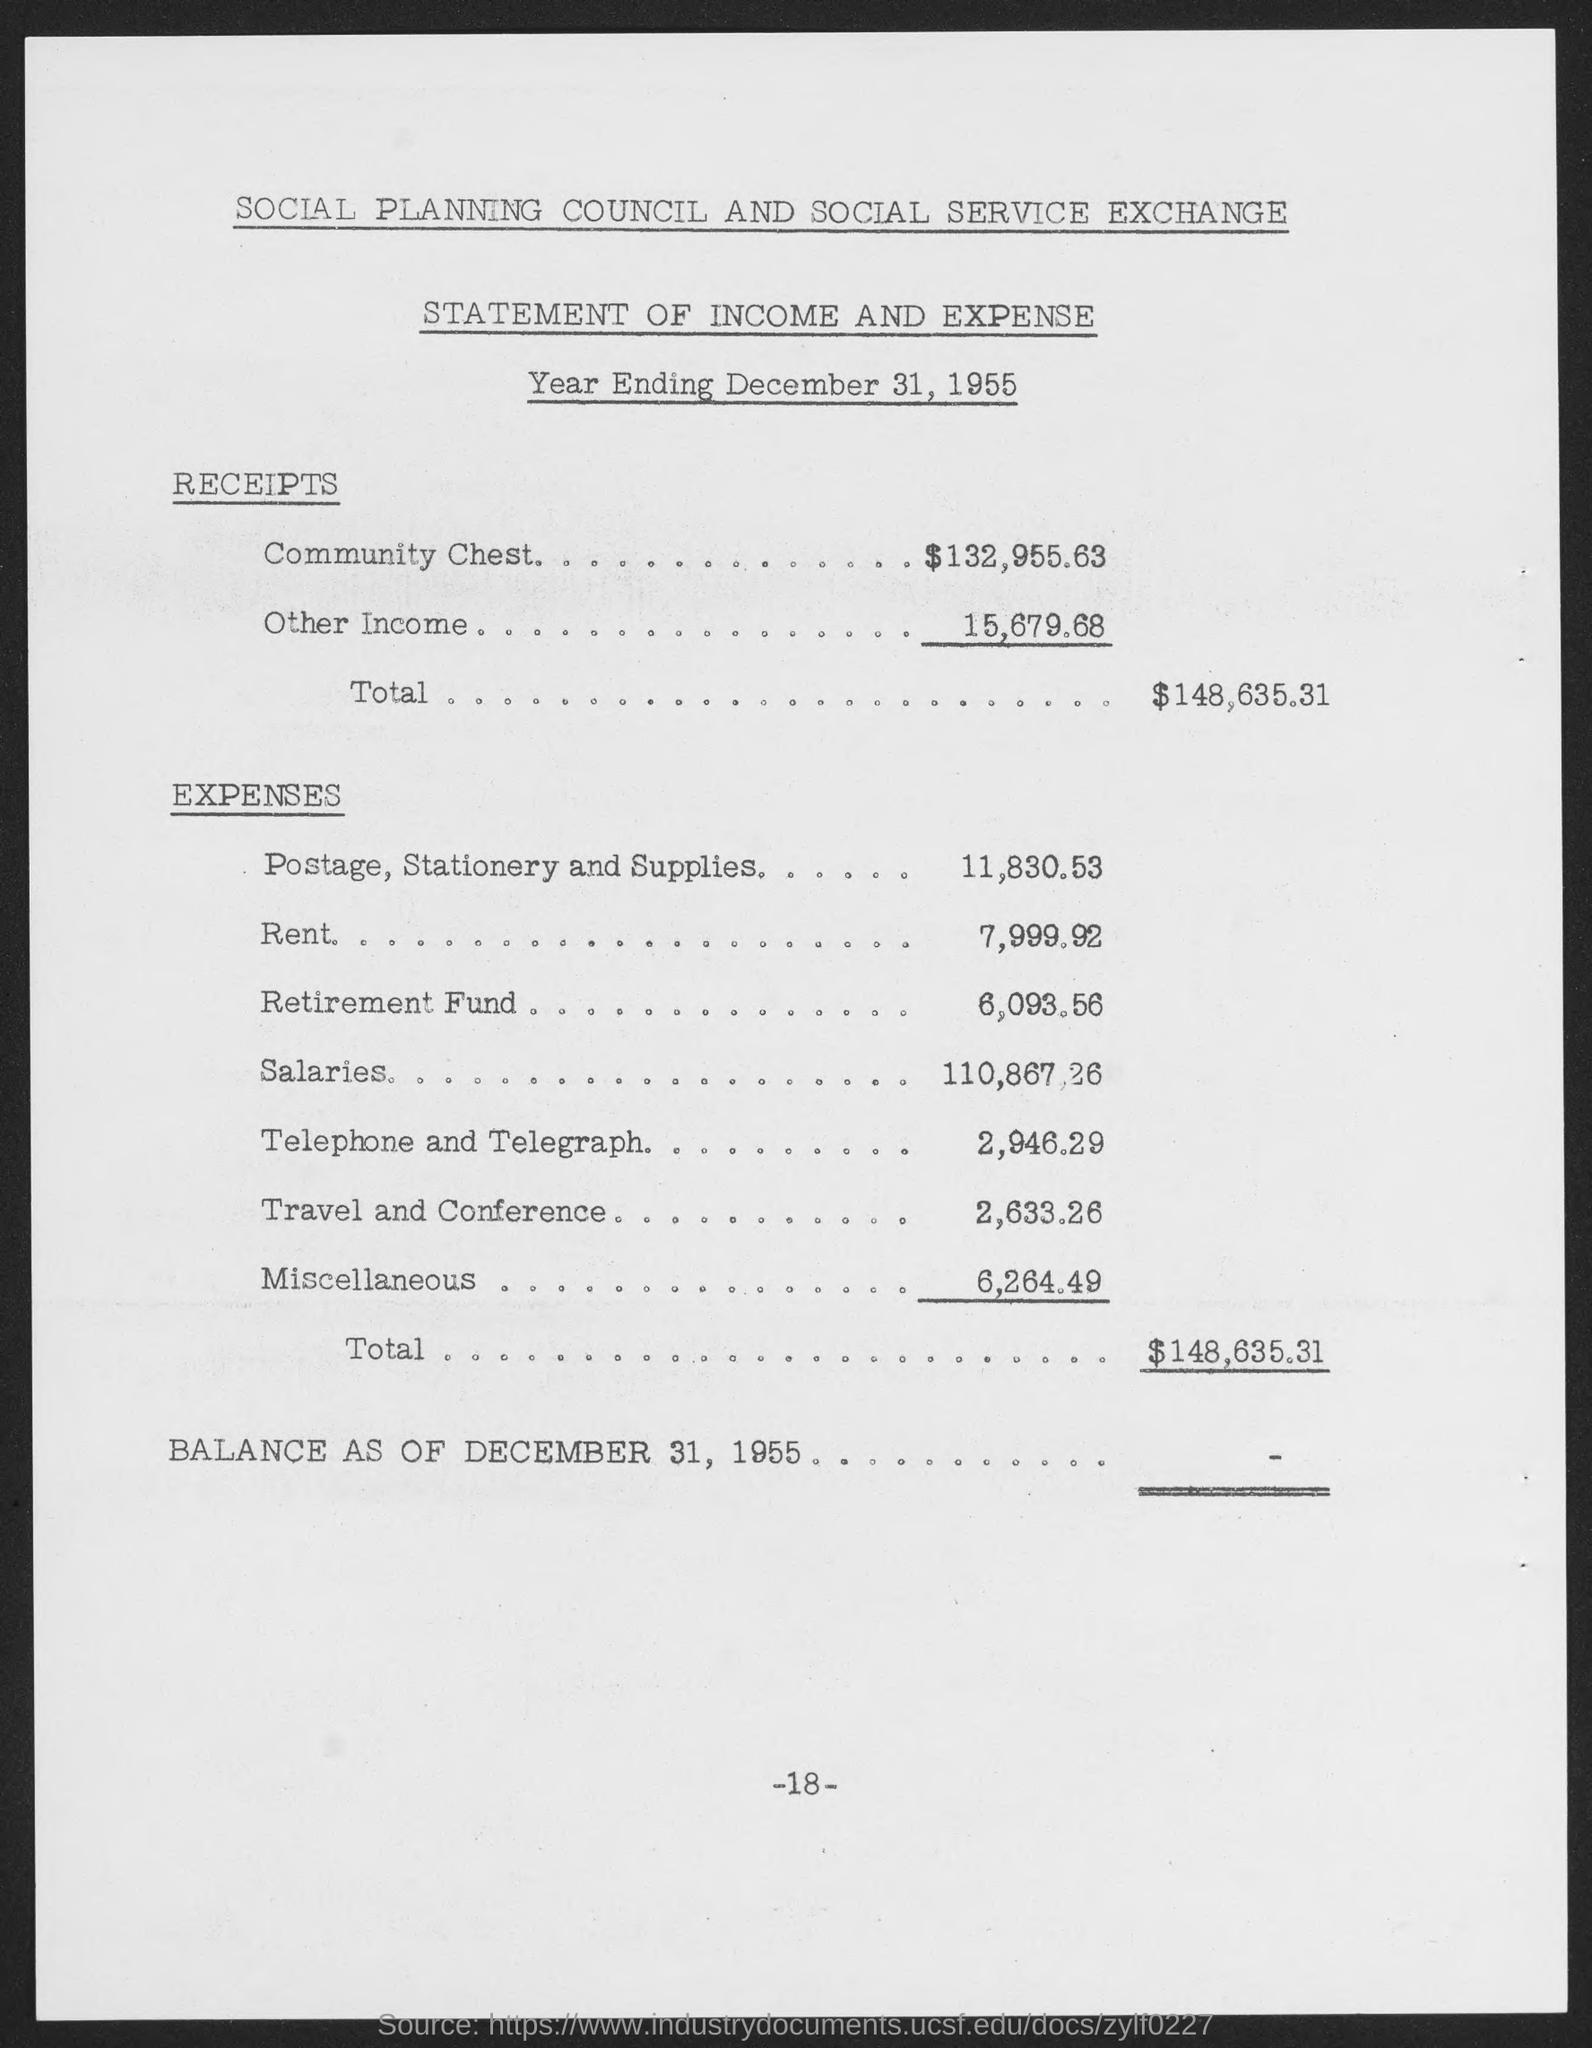What is the amount of total receipts ?
Offer a terse response. $148,635.31. What is the total amount of expenses?
Keep it short and to the point. $148,635.31. What is the amount of expense for postage, stationery and supplies?
Offer a very short reply. $11,830.53. What is the amount of expense for rent ?
Ensure brevity in your answer.  7,999.92. What is the amount of expense for retirement fund?
Provide a succinct answer. 6093.56. What is the amount of expense for salaries ?
Offer a very short reply. 110,867.26. What is the amount of expense for telephone and telegraph?
Ensure brevity in your answer.  2,946.29. What is the amount of expense for travel and conference ?
Offer a terse response. 2,633.26. What is the amount of expense for miscellaneous ?
Offer a terse response. 6,264.49. What is the receipts amount under other income?
Keep it short and to the point. 15,679.68. 